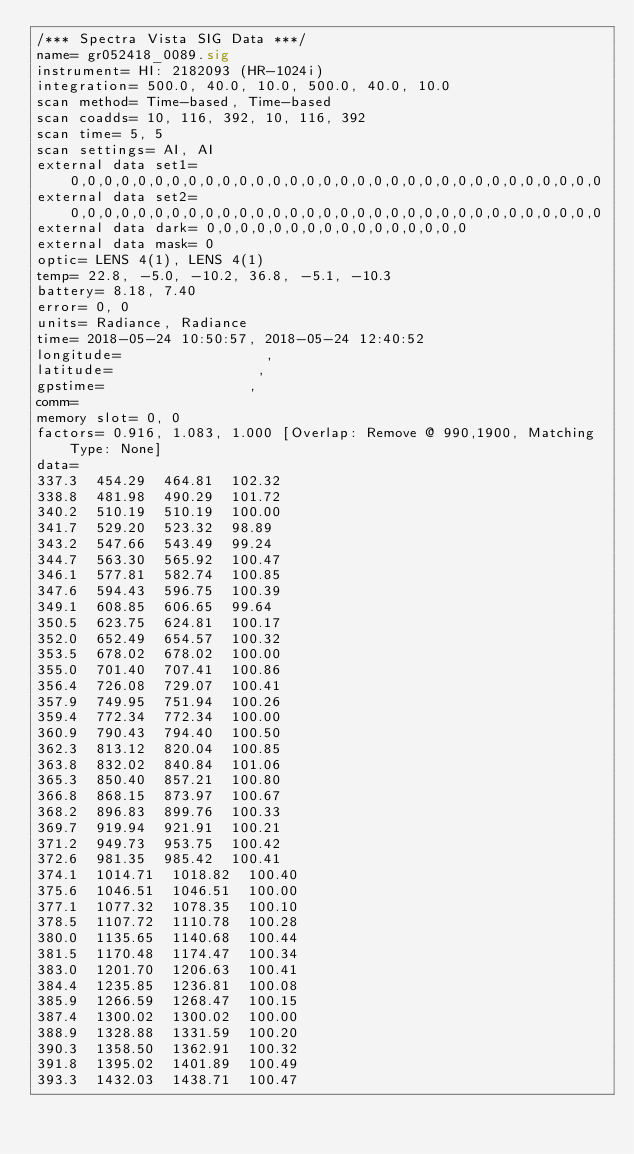<code> <loc_0><loc_0><loc_500><loc_500><_SML_>/*** Spectra Vista SIG Data ***/
name= gr052418_0089.sig
instrument= HI: 2182093 (HR-1024i)
integration= 500.0, 40.0, 10.0, 500.0, 40.0, 10.0
scan method= Time-based, Time-based
scan coadds= 10, 116, 392, 10, 116, 392
scan time= 5, 5
scan settings= AI, AI
external data set1= 0,0,0,0,0,0,0,0,0,0,0,0,0,0,0,0,0,0,0,0,0,0,0,0,0,0,0,0,0,0,0,0
external data set2= 0,0,0,0,0,0,0,0,0,0,0,0,0,0,0,0,0,0,0,0,0,0,0,0,0,0,0,0,0,0,0,0
external data dark= 0,0,0,0,0,0,0,0,0,0,0,0,0,0,0,0
external data mask= 0
optic= LENS 4(1), LENS 4(1)
temp= 22.8, -5.0, -10.2, 36.8, -5.1, -10.3
battery= 8.18, 7.40
error= 0, 0
units= Radiance, Radiance
time= 2018-05-24 10:50:57, 2018-05-24 12:40:52
longitude=                 ,                 
latitude=                 ,                 
gpstime=                 ,                 
comm= 
memory slot= 0, 0
factors= 0.916, 1.083, 1.000 [Overlap: Remove @ 990,1900, Matching Type: None]
data= 
337.3  454.29  464.81  102.32
338.8  481.98  490.29  101.72
340.2  510.19  510.19  100.00
341.7  529.20  523.32  98.89
343.2  547.66  543.49  99.24
344.7  563.30  565.92  100.47
346.1  577.81  582.74  100.85
347.6  594.43  596.75  100.39
349.1  608.85  606.65  99.64
350.5  623.75  624.81  100.17
352.0  652.49  654.57  100.32
353.5  678.02  678.02  100.00
355.0  701.40  707.41  100.86
356.4  726.08  729.07  100.41
357.9  749.95  751.94  100.26
359.4  772.34  772.34  100.00
360.9  790.43  794.40  100.50
362.3  813.12  820.04  100.85
363.8  832.02  840.84  101.06
365.3  850.40  857.21  100.80
366.8  868.15  873.97  100.67
368.2  896.83  899.76  100.33
369.7  919.94  921.91  100.21
371.2  949.73  953.75  100.42
372.6  981.35  985.42  100.41
374.1  1014.71  1018.82  100.40
375.6  1046.51  1046.51  100.00
377.1  1077.32  1078.35  100.10
378.5  1107.72  1110.78  100.28
380.0  1135.65  1140.68  100.44
381.5  1170.48  1174.47  100.34
383.0  1201.70  1206.63  100.41
384.4  1235.85  1236.81  100.08
385.9  1266.59  1268.47  100.15
387.4  1300.02  1300.02  100.00
388.9  1328.88  1331.59  100.20
390.3  1358.50  1362.91  100.32
391.8  1395.02  1401.89  100.49
393.3  1432.03  1438.71  100.47</code> 